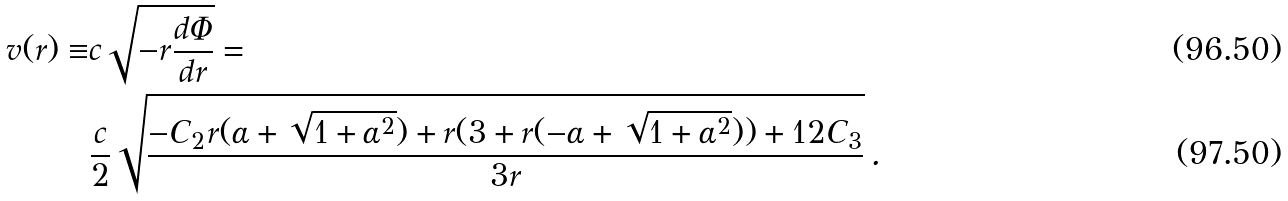<formula> <loc_0><loc_0><loc_500><loc_500>v ( r ) \equiv & c \sqrt { - r \frac { d \Phi } { d r } } = \\ & \frac { c } { 2 } \sqrt { \frac { - C _ { 2 } r ( \alpha + \sqrt { 1 + { \alpha } ^ { 2 } } ) + r ( 3 + r ( - \alpha + \sqrt { 1 + { \alpha } ^ { 2 } } ) ) + 1 2 C _ { 3 } } { 3 r } } \, .</formula> 